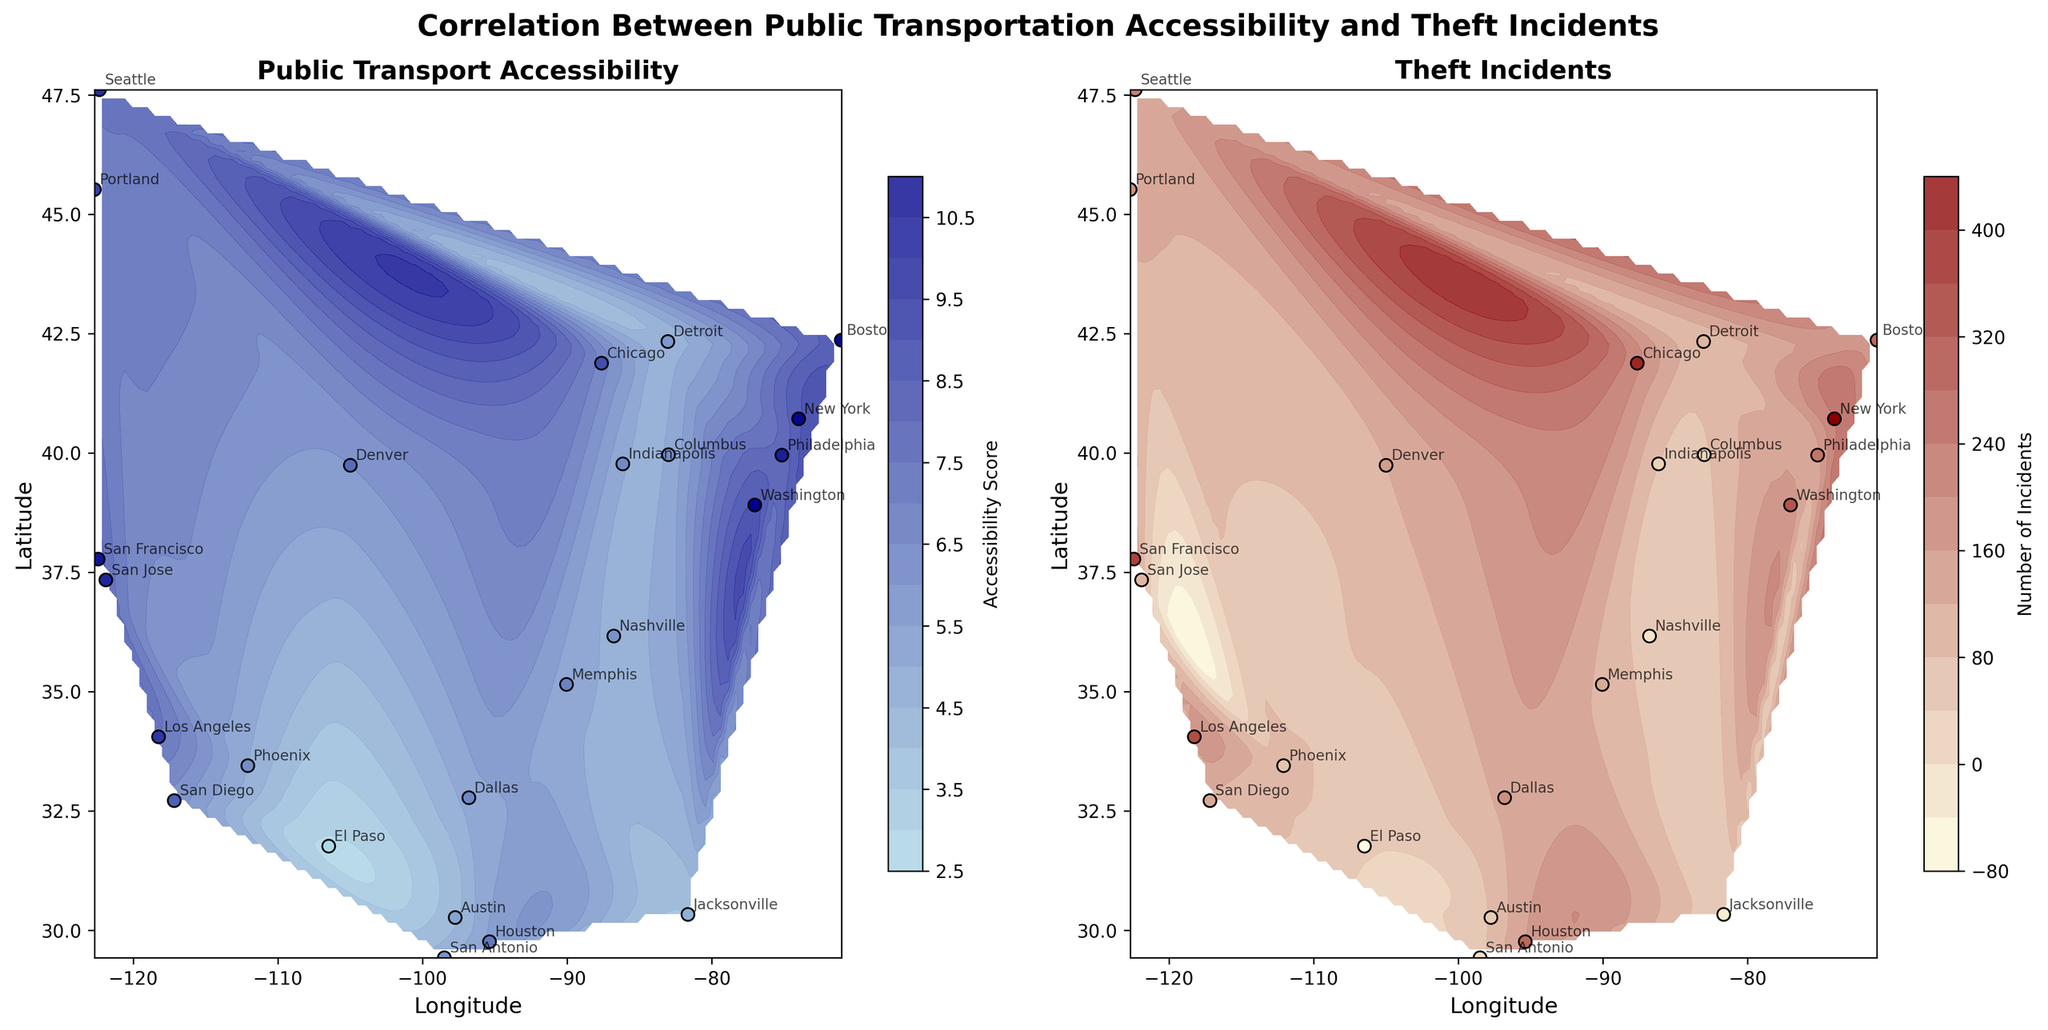What is the title of the figure? The title can be found at the top of the figure in bold, which summarizes the overall content and purpose of the figure.
Answer: Correlation Between Public Transportation Accessibility and Theft Incidents What are the colors used in the contour plot of Public Transport Accessibility? By observing the colormap used in the first subplot, we can see the gradient ranging from lighter to darker shades of blue.
Answer: Light blue to dark blue Which city has the highest public transport accessibility score? The city with the highest point on the contour plot with respect to the 'Public Transport Accessibility' subplot will indicate the highest score.
Answer: Washington Which city has the lowest number of theft incidents? On the 'Theft Incidents' subplot, the city with the smallest number of theft incidents will be identified with the lightest shade of the colormap used.
Answer: El Paso What is the range of the public transport accessibility scores represented in the contour plot? By examining the color bar legend on the first subplot, we can see the range of values it covers from minimum to maximum.
Answer: Approximately 2.9 to 9.1 Which city lies in the same longitude range but exhibits a noticeable difference in theft incidents compared to San Francisco? By matching cities on the same longitudinal line as San Francisco (-122.4194) in the 'Theft Incidents' subplot, we identify any differences visually.
Answer: San Diego How does the density of points correlate with color intensity in the provided subplots? Points densely clustered together often reflect more intense coloration in the areas of the contour plot, which signifies higher accessibility or more theft incidents, respectively.
Answer: More dense points generally mean more intense coloration Does any city show a high score in both public transport accessibility and theft incidents? By comparing positions of the cities on both subplots, we can identify if a city consistently appears in darker regions or higher scales in both metrics.
Answer: New York Which subplot has cities more evenly distributed geographically? By visually comparing both subplots, the spatial distribution of cities in terms of their coordinates on the geographic layout can be analyzed.
Answer: Public Transport Accessibility subplot What does the annotation in the subplots represent, and how do they supplement the visual data? The annotations provide the names of the cities exactly on their respective coordinates, thus aiding identification and reference directly within the figure.
Answer: City names 